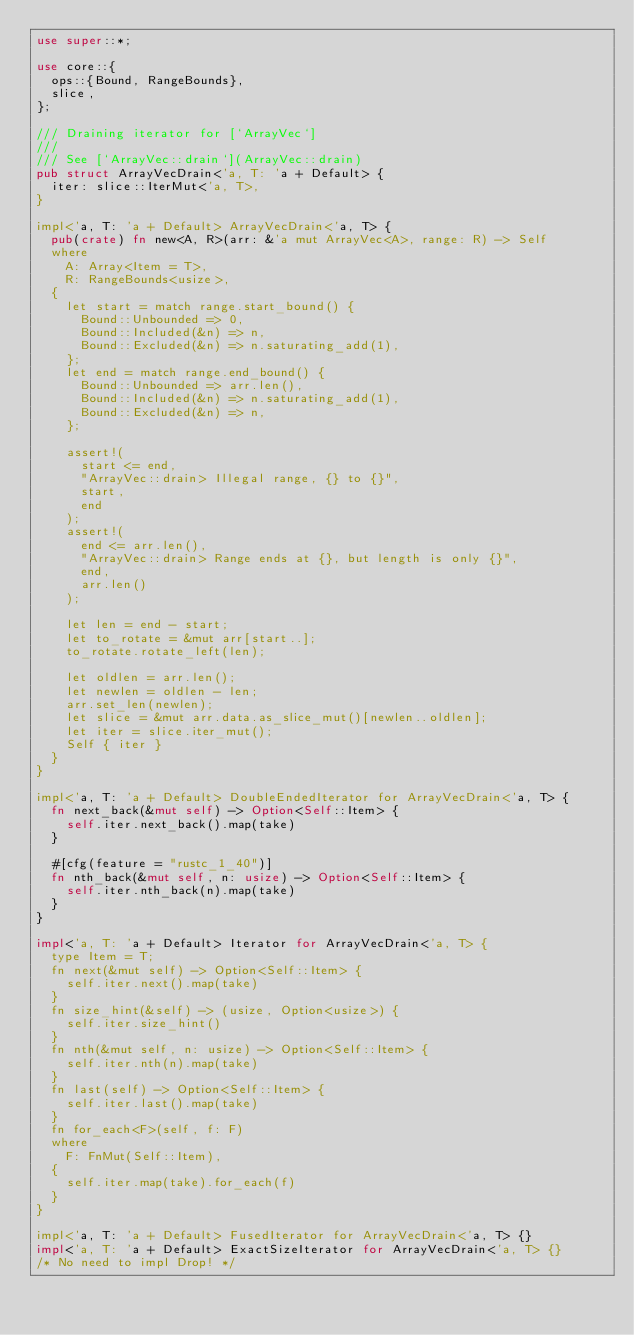Convert code to text. <code><loc_0><loc_0><loc_500><loc_500><_Rust_>use super::*;

use core::{
  ops::{Bound, RangeBounds},
  slice,
};

/// Draining iterator for [`ArrayVec`]
///
/// See [`ArrayVec::drain`](ArrayVec::drain)
pub struct ArrayVecDrain<'a, T: 'a + Default> {
  iter: slice::IterMut<'a, T>,
}

impl<'a, T: 'a + Default> ArrayVecDrain<'a, T> {
  pub(crate) fn new<A, R>(arr: &'a mut ArrayVec<A>, range: R) -> Self
  where
    A: Array<Item = T>,
    R: RangeBounds<usize>,
  {
    let start = match range.start_bound() {
      Bound::Unbounded => 0,
      Bound::Included(&n) => n,
      Bound::Excluded(&n) => n.saturating_add(1),
    };
    let end = match range.end_bound() {
      Bound::Unbounded => arr.len(),
      Bound::Included(&n) => n.saturating_add(1),
      Bound::Excluded(&n) => n,
    };

    assert!(
      start <= end,
      "ArrayVec::drain> Illegal range, {} to {}",
      start,
      end
    );
    assert!(
      end <= arr.len(),
      "ArrayVec::drain> Range ends at {}, but length is only {}",
      end,
      arr.len()
    );

    let len = end - start;
    let to_rotate = &mut arr[start..];
    to_rotate.rotate_left(len);

    let oldlen = arr.len();
    let newlen = oldlen - len;
    arr.set_len(newlen);
    let slice = &mut arr.data.as_slice_mut()[newlen..oldlen];
    let iter = slice.iter_mut();
    Self { iter }
  }
}

impl<'a, T: 'a + Default> DoubleEndedIterator for ArrayVecDrain<'a, T> {
  fn next_back(&mut self) -> Option<Self::Item> {
    self.iter.next_back().map(take)
  }

  #[cfg(feature = "rustc_1_40")]
  fn nth_back(&mut self, n: usize) -> Option<Self::Item> {
    self.iter.nth_back(n).map(take)
  }
}

impl<'a, T: 'a + Default> Iterator for ArrayVecDrain<'a, T> {
  type Item = T;
  fn next(&mut self) -> Option<Self::Item> {
    self.iter.next().map(take)
  }
  fn size_hint(&self) -> (usize, Option<usize>) {
    self.iter.size_hint()
  }
  fn nth(&mut self, n: usize) -> Option<Self::Item> {
    self.iter.nth(n).map(take)
  }
  fn last(self) -> Option<Self::Item> {
    self.iter.last().map(take)
  }
  fn for_each<F>(self, f: F)
  where
    F: FnMut(Self::Item),
  {
    self.iter.map(take).for_each(f)
  }
}

impl<'a, T: 'a + Default> FusedIterator for ArrayVecDrain<'a, T> {}
impl<'a, T: 'a + Default> ExactSizeIterator for ArrayVecDrain<'a, T> {}
/* No need to impl Drop! */
</code> 